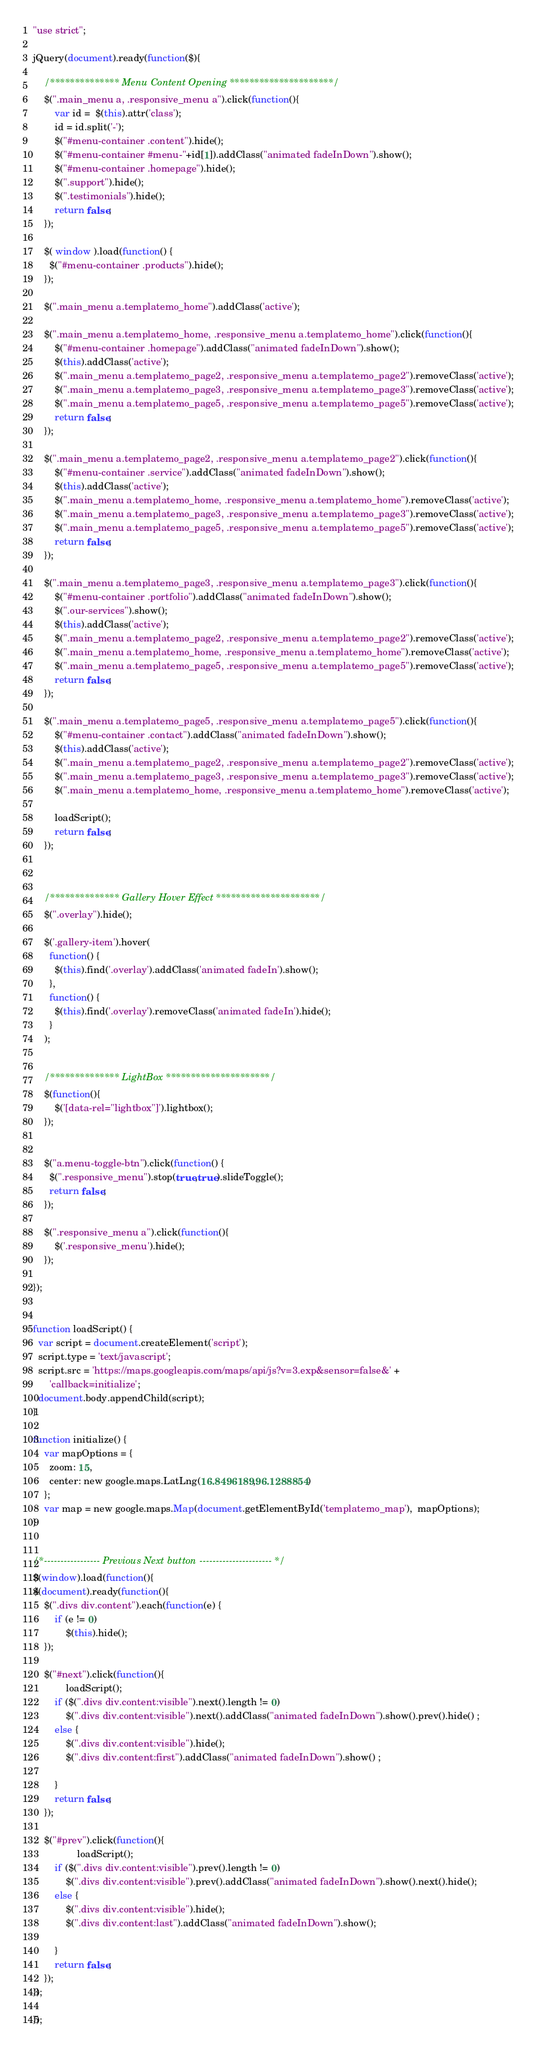Convert code to text. <code><loc_0><loc_0><loc_500><loc_500><_JavaScript_>"use strict";

jQuery(document).ready(function($){

	/************** Menu Content Opening *********************/
	$(".main_menu a, .responsive_menu a").click(function(){
		var id =  $(this).attr('class');
		id = id.split('-');
		$("#menu-container .content").hide();
		$("#menu-container #menu-"+id[1]).addClass("animated fadeInDown").show();
		$("#menu-container .homepage").hide();
		$(".support").hide();
		$(".testimonials").hide();
		return false;
	});

	$( window ).load(function() {
	  $("#menu-container .products").hide();
	});

	$(".main_menu a.templatemo_home").addClass('active');

	$(".main_menu a.templatemo_home, .responsive_menu a.templatemo_home").click(function(){
		$("#menu-container .homepage").addClass("animated fadeInDown").show();
		$(this).addClass('active');
		$(".main_menu a.templatemo_page2, .responsive_menu a.templatemo_page2").removeClass('active');
		$(".main_menu a.templatemo_page3, .responsive_menu a.templatemo_page3").removeClass('active');
		$(".main_menu a.templatemo_page5, .responsive_menu a.templatemo_page5").removeClass('active');
		return false;
	});

	$(".main_menu a.templatemo_page2, .responsive_menu a.templatemo_page2").click(function(){
		$("#menu-container .service").addClass("animated fadeInDown").show();
		$(this).addClass('active');
		$(".main_menu a.templatemo_home, .responsive_menu a.templatemo_home").removeClass('active');
		$(".main_menu a.templatemo_page3, .responsive_menu a.templatemo_page3").removeClass('active');
		$(".main_menu a.templatemo_page5, .responsive_menu a.templatemo_page5").removeClass('active');
		return false;
	});

	$(".main_menu a.templatemo_page3, .responsive_menu a.templatemo_page3").click(function(){
		$("#menu-container .portfolio").addClass("animated fadeInDown").show();
		$(".our-services").show();
		$(this).addClass('active');
		$(".main_menu a.templatemo_page2, .responsive_menu a.templatemo_page2").removeClass('active');
		$(".main_menu a.templatemo_home, .responsive_menu a.templatemo_home").removeClass('active');
		$(".main_menu a.templatemo_page5, .responsive_menu a.templatemo_page5").removeClass('active');
		return false;
	});

	$(".main_menu a.templatemo_page5, .responsive_menu a.templatemo_page5").click(function(){
		$("#menu-container .contact").addClass("animated fadeInDown").show();
		$(this).addClass('active');
		$(".main_menu a.templatemo_page2, .responsive_menu a.templatemo_page2").removeClass('active');
		$(".main_menu a.templatemo_page3, .responsive_menu a.templatemo_page3").removeClass('active');
		$(".main_menu a.templatemo_home, .responsive_menu a.templatemo_home").removeClass('active');
		
		loadScript();
		return false;
	});



	/************** Gallery Hover Effect *********************/
	$(".overlay").hide();

	$('.gallery-item').hover(
	  function() {
	    $(this).find('.overlay').addClass('animated fadeIn').show();
	  },
	  function() {
	    $(this).find('.overlay').removeClass('animated fadeIn').hide();
	  }
	);


	/************** LightBox *********************/
	$(function(){
		$('[data-rel="lightbox"]').lightbox();
	});


	$("a.menu-toggle-btn").click(function() {
	  $(".responsive_menu").stop(true,true).slideToggle();
	  return false;
	});
 
    $(".responsive_menu a").click(function(){
		$('.responsive_menu').hide();
	});

});


function loadScript() {
  var script = document.createElement('script');
  script.type = 'text/javascript';
  script.src = 'https://maps.googleapis.com/maps/api/js?v=3.exp&sensor=false&' +
      'callback=initialize';
  document.body.appendChild(script);
}

function initialize() {
    var mapOptions = {
      zoom: 15,
      center: new google.maps.LatLng(16.8496189,96.1288854)
    };
    var map = new google.maps.Map(document.getElementById('templatemo_map'),  mapOptions);
}


/*----------------- Previous Next button ---------------------- */
$(window).load(function(){
$(document).ready(function(){				   
    $(".divs div.content").each(function(e) {
        if (e != 0)
            $(this).hide();
    });
    
    $("#next").click(function(){
			loadScript();
        if ($(".divs div.content:visible").next().length != 0)
            $(".divs div.content:visible").next().addClass("animated fadeInDown").show().prev().hide() ;
        else {
            $(".divs div.content:visible").hide();
            $(".divs div.content:first").addClass("animated fadeInDown").show() ;
			
        }
        return false;
    });

    $("#prev").click(function(){
				loadScript();				  
        if ($(".divs div.content:visible").prev().length != 0)
            $(".divs div.content:visible").prev().addClass("animated fadeInDown").show().next().hide();
        else {
            $(".divs div.content:visible").hide();
            $(".divs div.content:last").addClass("animated fadeInDown").show();
			
        }
        return false;
    });
});

});
</code> 